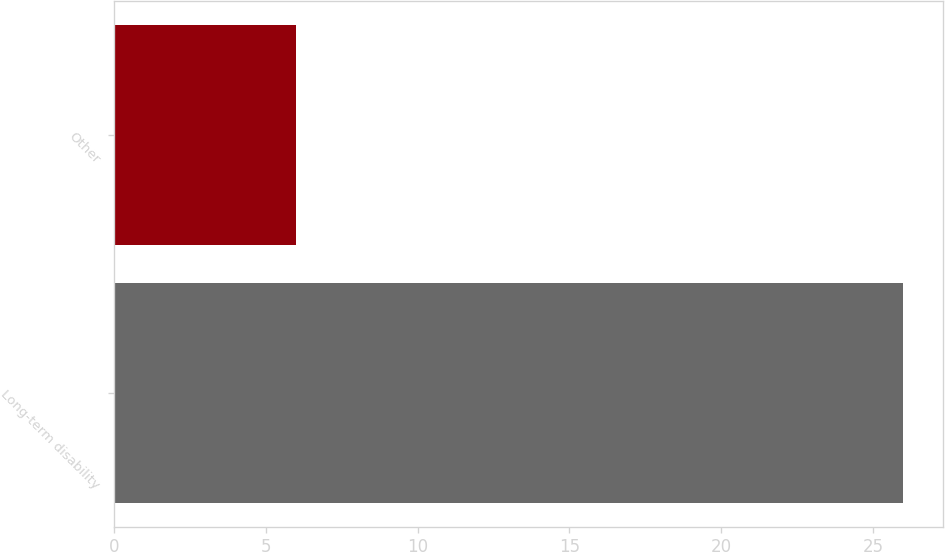<chart> <loc_0><loc_0><loc_500><loc_500><bar_chart><fcel>Long-term disability<fcel>Other<nl><fcel>26<fcel>6<nl></chart> 